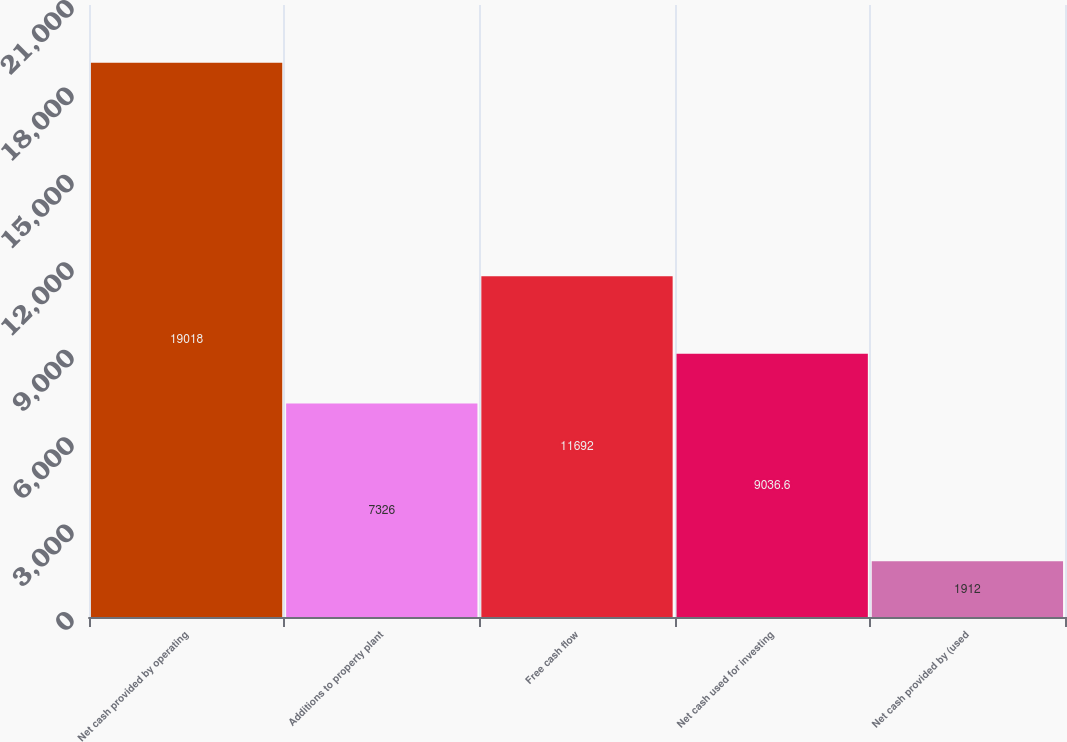Convert chart to OTSL. <chart><loc_0><loc_0><loc_500><loc_500><bar_chart><fcel>Net cash provided by operating<fcel>Additions to property plant<fcel>Free cash flow<fcel>Net cash used for investing<fcel>Net cash provided by (used<nl><fcel>19018<fcel>7326<fcel>11692<fcel>9036.6<fcel>1912<nl></chart> 